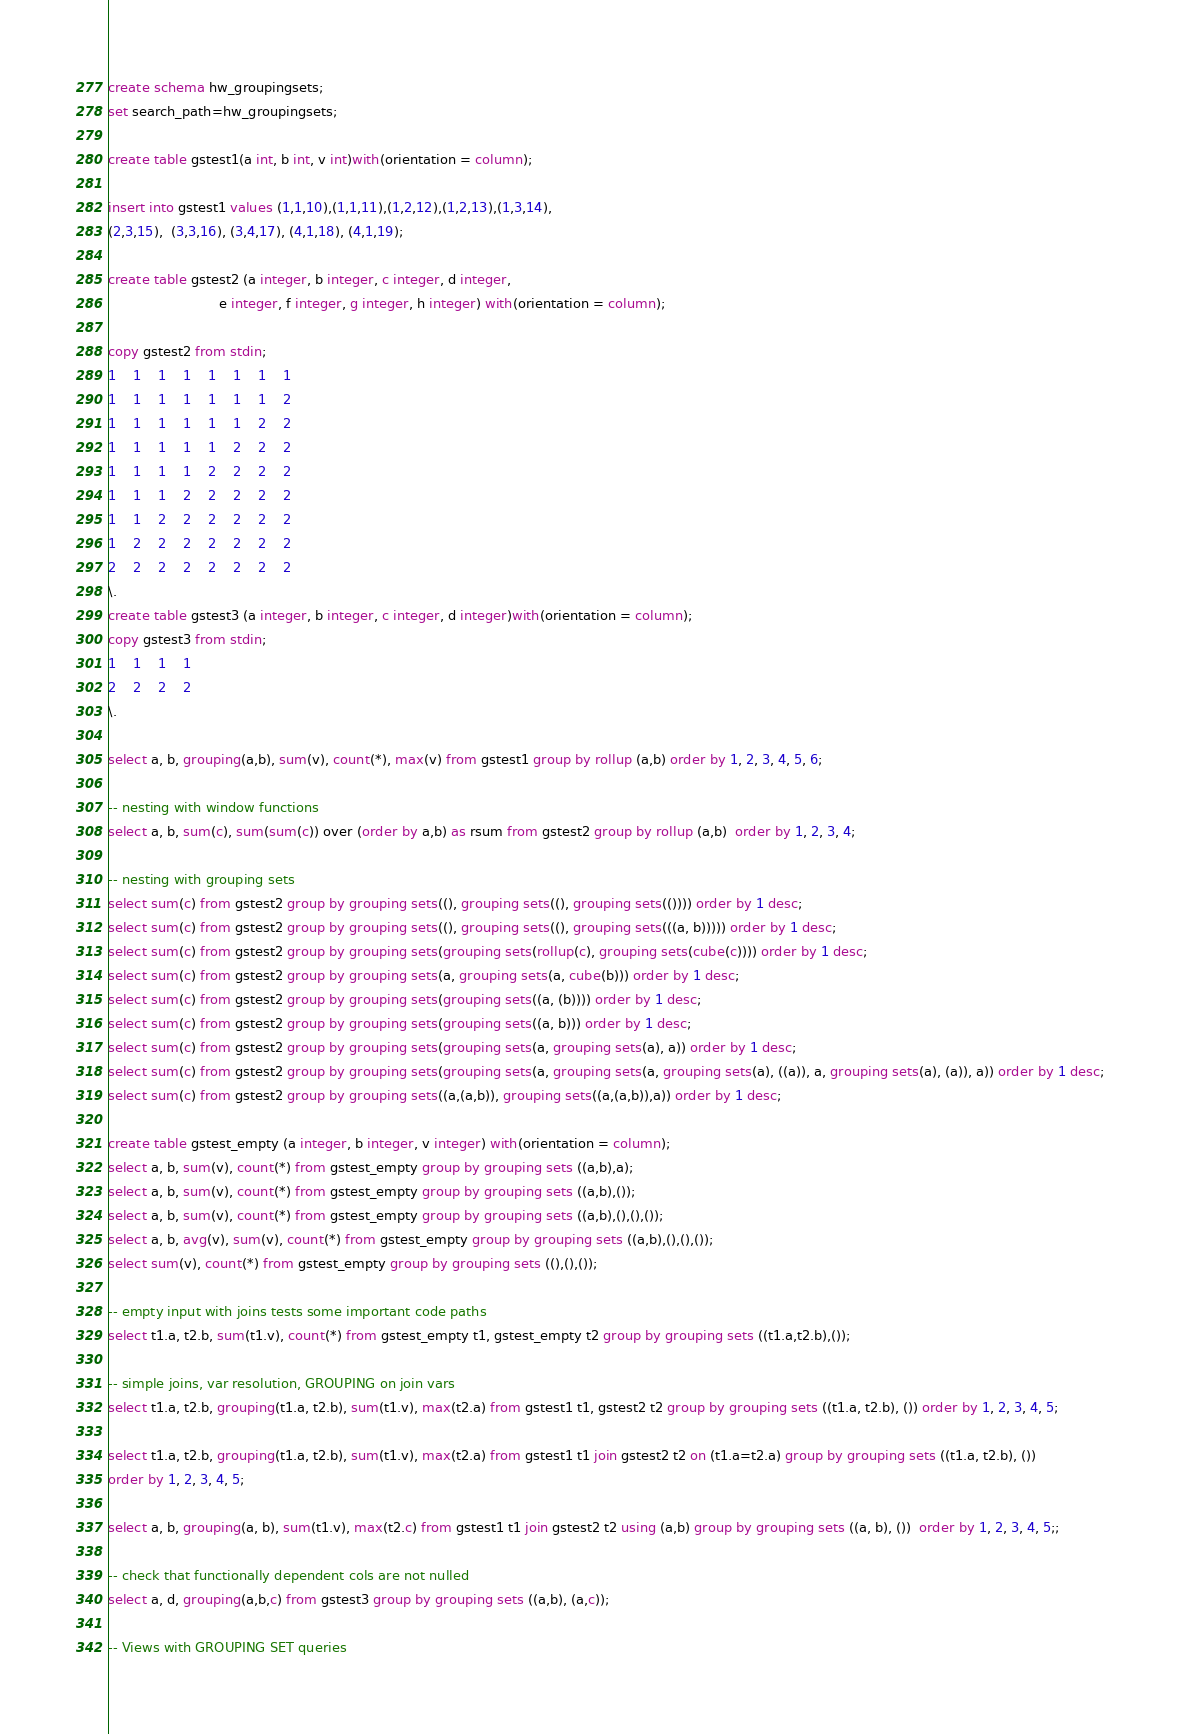Convert code to text. <code><loc_0><loc_0><loc_500><loc_500><_SQL_>create schema hw_groupingsets;
set search_path=hw_groupingsets;

create table gstest1(a int, b int, v int)with(orientation = column);

insert into gstest1 values (1,1,10),(1,1,11),(1,2,12),(1,2,13),(1,3,14),
(2,3,15),  (3,3,16), (3,4,17), (4,1,18), (4,1,19);

create table gstest2 (a integer, b integer, c integer, d integer,
                           e integer, f integer, g integer, h integer) with(orientation = column);

copy gstest2 from stdin;
1	1	1	1	1	1	1	1
1	1	1	1	1	1	1	2
1	1	1	1	1	1	2	2
1	1	1	1	1	2	2	2
1	1	1	1	2	2	2	2
1	1	1	2	2	2	2	2
1	1	2	2	2	2	2	2
1	2	2	2	2	2	2	2
2	2	2	2	2	2	2	2
\.
create table gstest3 (a integer, b integer, c integer, d integer)with(orientation = column);
copy gstest3 from stdin;
1	1	1	1
2	2	2	2
\.

select a, b, grouping(a,b), sum(v), count(*), max(v) from gstest1 group by rollup (a,b) order by 1, 2, 3, 4, 5, 6;

-- nesting with window functions
select a, b, sum(c), sum(sum(c)) over (order by a,b) as rsum from gstest2 group by rollup (a,b)  order by 1, 2, 3, 4;

-- nesting with grouping sets
select sum(c) from gstest2 group by grouping sets((), grouping sets((), grouping sets(()))) order by 1 desc;
select sum(c) from gstest2 group by grouping sets((), grouping sets((), grouping sets(((a, b))))) order by 1 desc;
select sum(c) from gstest2 group by grouping sets(grouping sets(rollup(c), grouping sets(cube(c)))) order by 1 desc;
select sum(c) from gstest2 group by grouping sets(a, grouping sets(a, cube(b))) order by 1 desc;
select sum(c) from gstest2 group by grouping sets(grouping sets((a, (b)))) order by 1 desc;
select sum(c) from gstest2 group by grouping sets(grouping sets((a, b))) order by 1 desc;
select sum(c) from gstest2 group by grouping sets(grouping sets(a, grouping sets(a), a)) order by 1 desc;
select sum(c) from gstest2 group by grouping sets(grouping sets(a, grouping sets(a, grouping sets(a), ((a)), a, grouping sets(a), (a)), a)) order by 1 desc;
select sum(c) from gstest2 group by grouping sets((a,(a,b)), grouping sets((a,(a,b)),a)) order by 1 desc;

create table gstest_empty (a integer, b integer, v integer) with(orientation = column);
select a, b, sum(v), count(*) from gstest_empty group by grouping sets ((a,b),a);
select a, b, sum(v), count(*) from gstest_empty group by grouping sets ((a,b),());
select a, b, sum(v), count(*) from gstest_empty group by grouping sets ((a,b),(),(),());
select a, b, avg(v), sum(v), count(*) from gstest_empty group by grouping sets ((a,b),(),(),());
select sum(v), count(*) from gstest_empty group by grouping sets ((),(),());

-- empty input with joins tests some important code paths
select t1.a, t2.b, sum(t1.v), count(*) from gstest_empty t1, gstest_empty t2 group by grouping sets ((t1.a,t2.b),());

-- simple joins, var resolution, GROUPING on join vars
select t1.a, t2.b, grouping(t1.a, t2.b), sum(t1.v), max(t2.a) from gstest1 t1, gstest2 t2 group by grouping sets ((t1.a, t2.b), ()) order by 1, 2, 3, 4, 5;

select t1.a, t2.b, grouping(t1.a, t2.b), sum(t1.v), max(t2.a) from gstest1 t1 join gstest2 t2 on (t1.a=t2.a) group by grouping sets ((t1.a, t2.b), ())
order by 1, 2, 3, 4, 5;

select a, b, grouping(a, b), sum(t1.v), max(t2.c) from gstest1 t1 join gstest2 t2 using (a,b) group by grouping sets ((a, b), ())  order by 1, 2, 3, 4, 5;;

-- check that functionally dependent cols are not nulled
select a, d, grouping(a,b,c) from gstest3 group by grouping sets ((a,b), (a,c));

-- Views with GROUPING SET queries</code> 